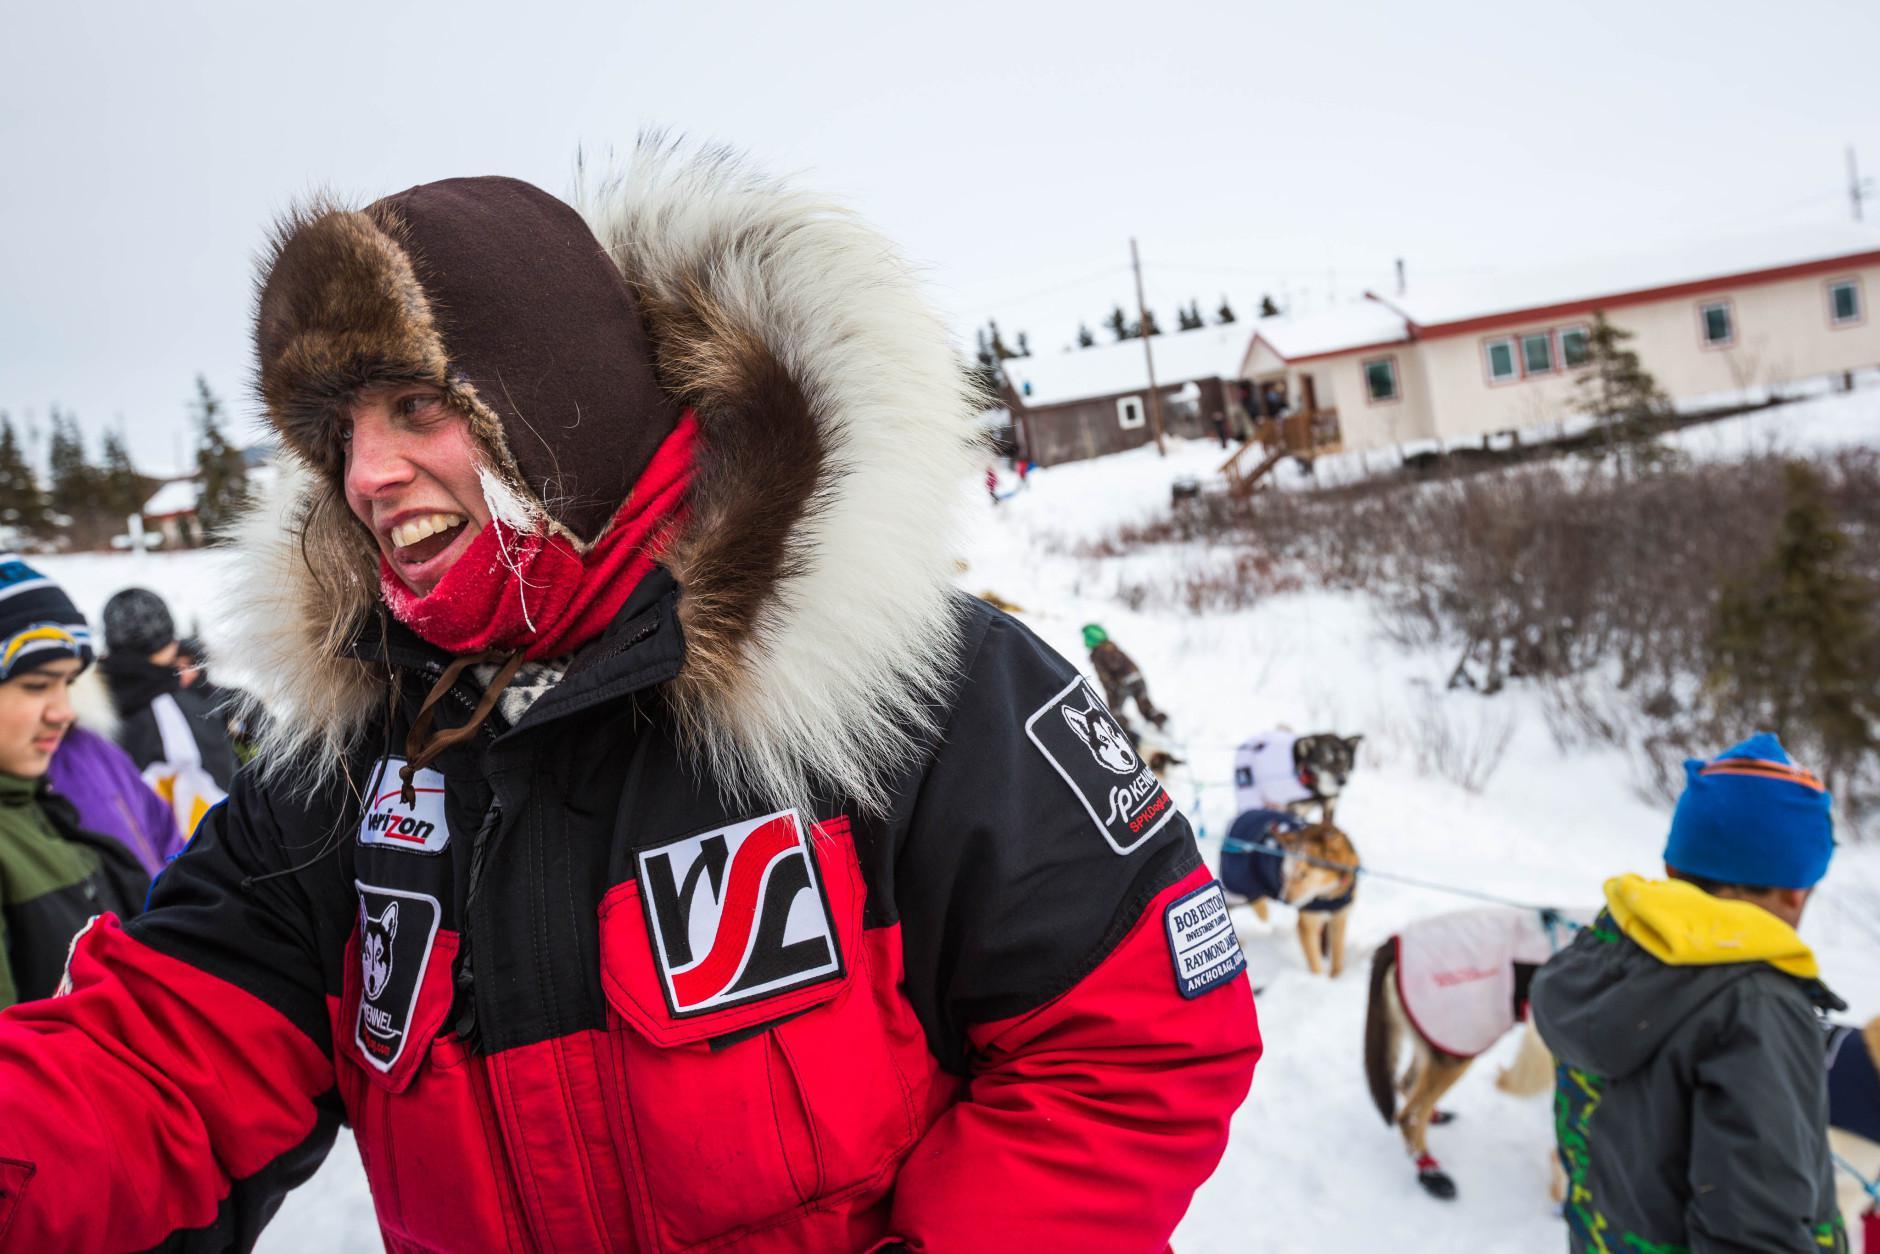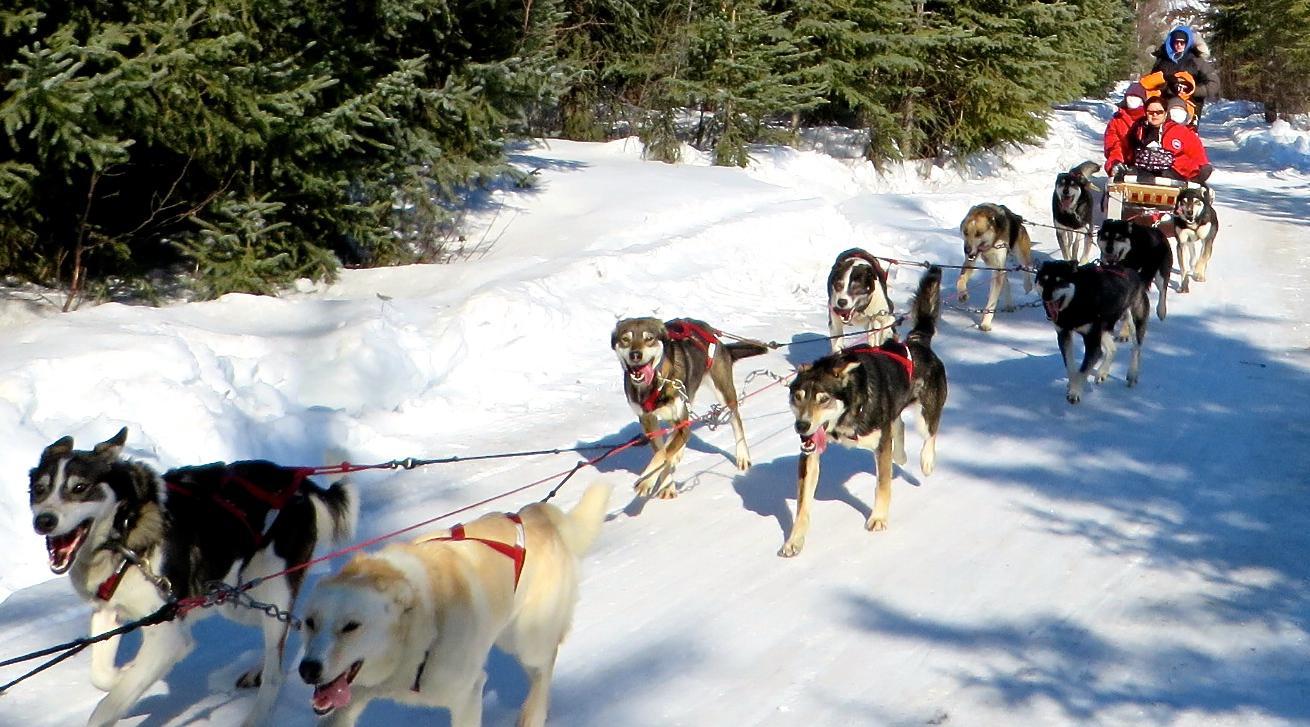The first image is the image on the left, the second image is the image on the right. For the images displayed, is the sentence "A person in a red and black jacket is in the foreground of one image." factually correct? Answer yes or no. Yes. 